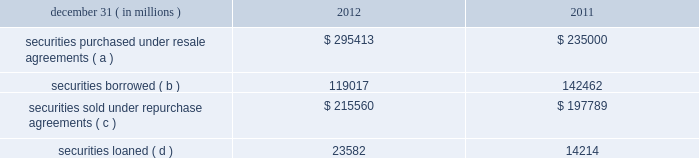Jpmorgan chase & co./2012 annual report 249 note 13 2013 securities financing activities jpmorgan chase enters into resale agreements , repurchase agreements , securities borrowed transactions and securities loaned transactions ( collectively , 201csecurities financing agreements 201d ) primarily to finance the firm 2019s inventory positions , acquire securities to cover short positions , accommodate customers 2019 financing needs , and settle other securities obligations .
Securities financing agreements are treated as collateralized financings on the firm 2019s consolidated balance sheets .
Resale and repurchase agreements are generally carried at the amounts at which the securities will be subsequently sold or repurchased , plus accrued interest .
Securities borrowed and securities loaned transactions are generally carried at the amount of cash collateral advanced or received .
Where appropriate under applicable accounting guidance , resale and repurchase agreements with the same counterparty are reported on a net basis .
Fees received and paid in connection with securities financing agreements are recorded in interest income and interest expense , respectively .
The firm has elected the fair value option for certain securities financing agreements .
For further information regarding the fair value option , see note 4 on pages 214 2013 216 of this annual report .
The securities financing agreements for which the fair value option has been elected are reported within securities purchased under resale agreements ; securities loaned or sold under repurchase agreements ; and securities borrowed on the consolidated balance sheets .
Generally , for agreements carried at fair value , current-period interest accruals are recorded within interest income and interest expense , with changes in fair value reported in principal transactions revenue .
However , for financial instruments containing embedded derivatives that would be separately accounted for in accordance with accounting guidance for hybrid instruments , all changes in fair value , including any interest elements , are reported in principal transactions revenue .
The table details the firm 2019s securities financing agreements , all of which are accounted for as collateralized financings during the periods presented .
December 31 , ( in millions ) 2012 2011 securities purchased under resale agreements ( a ) $ 295413 $ 235000 securities borrowed ( b ) 119017 142462 securities sold under repurchase agreements ( c ) $ 215560 $ 197789 securities loaned ( d ) 23582 14214 ( a ) at december 31 , 2012 and 2011 , included resale agreements of $ 24.3 billion and $ 22.2 billion , respectively , accounted for at fair value .
( b ) at december 31 , 2012 and 2011 , included securities borrowed of $ 10.2 billion and $ 15.3 billion , respectively , accounted for at fair value .
( c ) at december 31 , 2012 and 2011 , included repurchase agreements of $ 3.9 billion and $ 6.8 billion , respectively , accounted for at fair value .
( d ) at december 31 , 2012 , included securities loaned of $ 457 million accounted for at fair value .
There were no securities loaned accounted for at fair value at december 31 , 2011 .
The amounts reported in the table above were reduced by $ 96.9 billion and $ 115.7 billion at december 31 , 2012 and 2011 , respectively , as a result of agreements in effect that meet the specified conditions for net presentation under applicable accounting guidance .
Jpmorgan chase 2019s policy is to take possession , where possible , of securities purchased under resale agreements and of securities borrowed .
The firm monitors the value of the underlying securities ( primarily g7 government securities , u.s .
Agency securities and agency mbs , and equities ) that it has received from its counterparties and either requests additional collateral or returns a portion of the collateral when appropriate in light of the market value of the underlying securities .
Margin levels are established initially based upon the counterparty and type of collateral and monitored on an ongoing basis to protect against declines in collateral value in the event of default .
Jpmorgan chase typically enters into master netting agreements and other collateral arrangements with its resale agreement and securities borrowed counterparties , which provide for the right to liquidate the purchased or borrowed securities in the event of a customer default .
As a result of the firm 2019s credit risk mitigation practices with respect to resale and securities borrowed agreements as described above , the firm did not hold any reserves for credit impairment with respect to these agreements as of december 31 , 2012 and for further information regarding assets pledged and collateral received in securities financing agreements , see note 30 on pages 315 2013316 of this annual report. .
Jpmorgan chase & co./2012 annual report 249 note 13 2013 securities financing activities jpmorgan chase enters into resale agreements , repurchase agreements , securities borrowed transactions and securities loaned transactions ( collectively , 201csecurities financing agreements 201d ) primarily to finance the firm 2019s inventory positions , acquire securities to cover short positions , accommodate customers 2019 financing needs , and settle other securities obligations .
Securities financing agreements are treated as collateralized financings on the firm 2019s consolidated balance sheets .
Resale and repurchase agreements are generally carried at the amounts at which the securities will be subsequently sold or repurchased , plus accrued interest .
Securities borrowed and securities loaned transactions are generally carried at the amount of cash collateral advanced or received .
Where appropriate under applicable accounting guidance , resale and repurchase agreements with the same counterparty are reported on a net basis .
Fees received and paid in connection with securities financing agreements are recorded in interest income and interest expense , respectively .
The firm has elected the fair value option for certain securities financing agreements .
For further information regarding the fair value option , see note 4 on pages 214 2013 216 of this annual report .
The securities financing agreements for which the fair value option has been elected are reported within securities purchased under resale agreements ; securities loaned or sold under repurchase agreements ; and securities borrowed on the consolidated balance sheets .
Generally , for agreements carried at fair value , current-period interest accruals are recorded within interest income and interest expense , with changes in fair value reported in principal transactions revenue .
However , for financial instruments containing embedded derivatives that would be separately accounted for in accordance with accounting guidance for hybrid instruments , all changes in fair value , including any interest elements , are reported in principal transactions revenue .
The following table details the firm 2019s securities financing agreements , all of which are accounted for as collateralized financings during the periods presented .
December 31 , ( in millions ) 2012 2011 securities purchased under resale agreements ( a ) $ 295413 $ 235000 securities borrowed ( b ) 119017 142462 securities sold under repurchase agreements ( c ) $ 215560 $ 197789 securities loaned ( d ) 23582 14214 ( a ) at december 31 , 2012 and 2011 , included resale agreements of $ 24.3 billion and $ 22.2 billion , respectively , accounted for at fair value .
( b ) at december 31 , 2012 and 2011 , included securities borrowed of $ 10.2 billion and $ 15.3 billion , respectively , accounted for at fair value .
( c ) at december 31 , 2012 and 2011 , included repurchase agreements of $ 3.9 billion and $ 6.8 billion , respectively , accounted for at fair value .
( d ) at december 31 , 2012 , included securities loaned of $ 457 million accounted for at fair value .
There were no securities loaned accounted for at fair value at december 31 , 2011 .
The amounts reported in the table above were reduced by $ 96.9 billion and $ 115.7 billion at december 31 , 2012 and 2011 , respectively , as a result of agreements in effect that meet the specified conditions for net presentation under applicable accounting guidance .
Jpmorgan chase 2019s policy is to take possession , where possible , of securities purchased under resale agreements and of securities borrowed .
The firm monitors the value of the underlying securities ( primarily g7 government securities , u.s .
Agency securities and agency mbs , and equities ) that it has received from its counterparties and either requests additional collateral or returns a portion of the collateral when appropriate in light of the market value of the underlying securities .
Margin levels are established initially based upon the counterparty and type of collateral and monitored on an ongoing basis to protect against declines in collateral value in the event of default .
Jpmorgan chase typically enters into master netting agreements and other collateral arrangements with its resale agreement and securities borrowed counterparties , which provide for the right to liquidate the purchased or borrowed securities in the event of a customer default .
As a result of the firm 2019s credit risk mitigation practices with respect to resale and securities borrowed agreements as described above , the firm did not hold any reserves for credit impairment with respect to these agreements as of december 31 , 2012 and for further information regarding assets pledged and collateral received in securities financing agreements , see note 30 on pages 315 2013316 of this annual report. .
In 2012 what was the ratio of the securities borrowed to the securities loaned? 
Computations: (119017 / 23582)
Answer: 5.04694. 